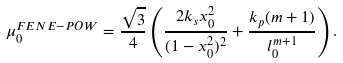<formula> <loc_0><loc_0><loc_500><loc_500>\mu _ { 0 } ^ { F E N E - P O W } = \frac { \sqrt { 3 } } { 4 } \left ( \frac { 2 k _ { s } x _ { 0 } ^ { 2 } } { ( 1 - x _ { 0 } ^ { 2 } ) ^ { 2 } } + \frac { k _ { p } ( m + 1 ) } { l _ { 0 } ^ { m + 1 } } \right ) .</formula> 